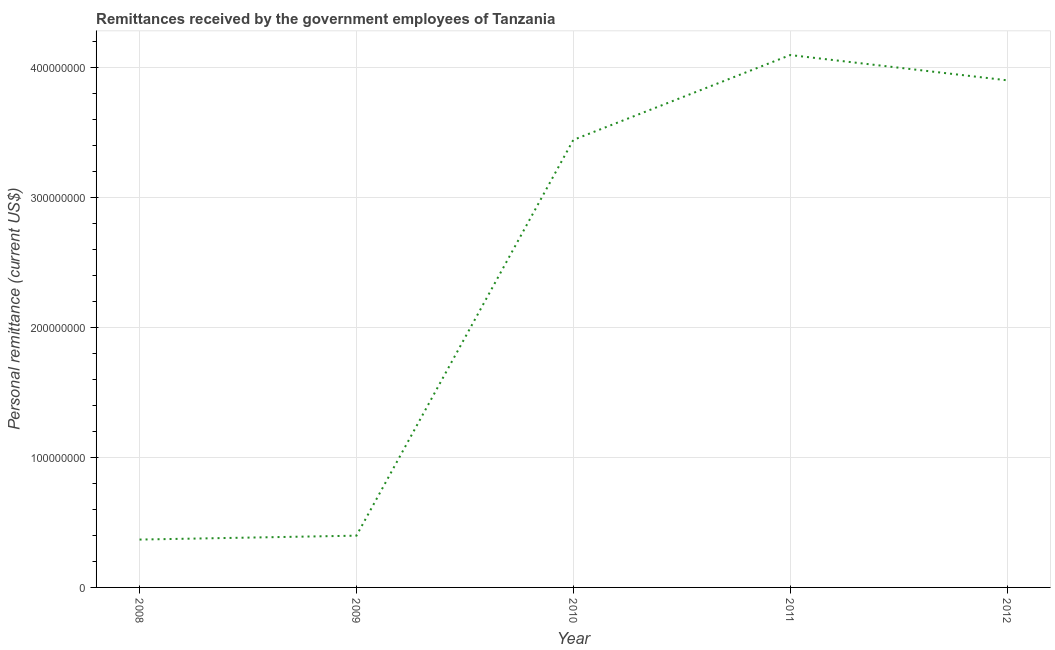What is the personal remittances in 2010?
Your answer should be very brief. 3.44e+08. Across all years, what is the maximum personal remittances?
Keep it short and to the point. 4.10e+08. Across all years, what is the minimum personal remittances?
Ensure brevity in your answer.  3.68e+07. What is the sum of the personal remittances?
Ensure brevity in your answer.  1.22e+09. What is the difference between the personal remittances in 2009 and 2012?
Keep it short and to the point. -3.50e+08. What is the average personal remittances per year?
Keep it short and to the point. 2.44e+08. What is the median personal remittances?
Keep it short and to the point. 3.44e+08. Do a majority of the years between 2011 and 2008 (inclusive) have personal remittances greater than 340000000 US$?
Your answer should be compact. Yes. What is the ratio of the personal remittances in 2010 to that in 2011?
Offer a terse response. 0.84. Is the personal remittances in 2009 less than that in 2010?
Ensure brevity in your answer.  Yes. Is the difference between the personal remittances in 2009 and 2011 greater than the difference between any two years?
Provide a succinct answer. No. What is the difference between the highest and the second highest personal remittances?
Offer a terse response. 1.94e+07. What is the difference between the highest and the lowest personal remittances?
Your response must be concise. 3.73e+08. Does the personal remittances monotonically increase over the years?
Keep it short and to the point. No. What is the difference between two consecutive major ticks on the Y-axis?
Ensure brevity in your answer.  1.00e+08. Are the values on the major ticks of Y-axis written in scientific E-notation?
Provide a short and direct response. No. Does the graph contain grids?
Your response must be concise. Yes. What is the title of the graph?
Ensure brevity in your answer.  Remittances received by the government employees of Tanzania. What is the label or title of the Y-axis?
Provide a short and direct response. Personal remittance (current US$). What is the Personal remittance (current US$) of 2008?
Give a very brief answer. 3.68e+07. What is the Personal remittance (current US$) of 2009?
Your answer should be compact. 3.98e+07. What is the Personal remittance (current US$) in 2010?
Give a very brief answer. 3.44e+08. What is the Personal remittance (current US$) in 2011?
Ensure brevity in your answer.  4.10e+08. What is the Personal remittance (current US$) of 2012?
Your answer should be compact. 3.90e+08. What is the difference between the Personal remittance (current US$) in 2008 and 2009?
Ensure brevity in your answer.  -3.01e+06. What is the difference between the Personal remittance (current US$) in 2008 and 2010?
Provide a short and direct response. -3.07e+08. What is the difference between the Personal remittance (current US$) in 2008 and 2011?
Provide a succinct answer. -3.73e+08. What is the difference between the Personal remittance (current US$) in 2008 and 2012?
Your response must be concise. -3.53e+08. What is the difference between the Personal remittance (current US$) in 2009 and 2010?
Offer a terse response. -3.04e+08. What is the difference between the Personal remittance (current US$) in 2009 and 2011?
Provide a short and direct response. -3.70e+08. What is the difference between the Personal remittance (current US$) in 2009 and 2012?
Your answer should be very brief. -3.50e+08. What is the difference between the Personal remittance (current US$) in 2010 and 2011?
Offer a very short reply. -6.53e+07. What is the difference between the Personal remittance (current US$) in 2010 and 2012?
Provide a succinct answer. -4.59e+07. What is the difference between the Personal remittance (current US$) in 2011 and 2012?
Your response must be concise. 1.94e+07. What is the ratio of the Personal remittance (current US$) in 2008 to that in 2009?
Offer a very short reply. 0.92. What is the ratio of the Personal remittance (current US$) in 2008 to that in 2010?
Keep it short and to the point. 0.11. What is the ratio of the Personal remittance (current US$) in 2008 to that in 2011?
Your answer should be very brief. 0.09. What is the ratio of the Personal remittance (current US$) in 2008 to that in 2012?
Make the answer very short. 0.09. What is the ratio of the Personal remittance (current US$) in 2009 to that in 2010?
Your answer should be very brief. 0.12. What is the ratio of the Personal remittance (current US$) in 2009 to that in 2011?
Keep it short and to the point. 0.1. What is the ratio of the Personal remittance (current US$) in 2009 to that in 2012?
Your answer should be very brief. 0.1. What is the ratio of the Personal remittance (current US$) in 2010 to that in 2011?
Your answer should be compact. 0.84. What is the ratio of the Personal remittance (current US$) in 2010 to that in 2012?
Your answer should be compact. 0.88. What is the ratio of the Personal remittance (current US$) in 2011 to that in 2012?
Provide a short and direct response. 1.05. 